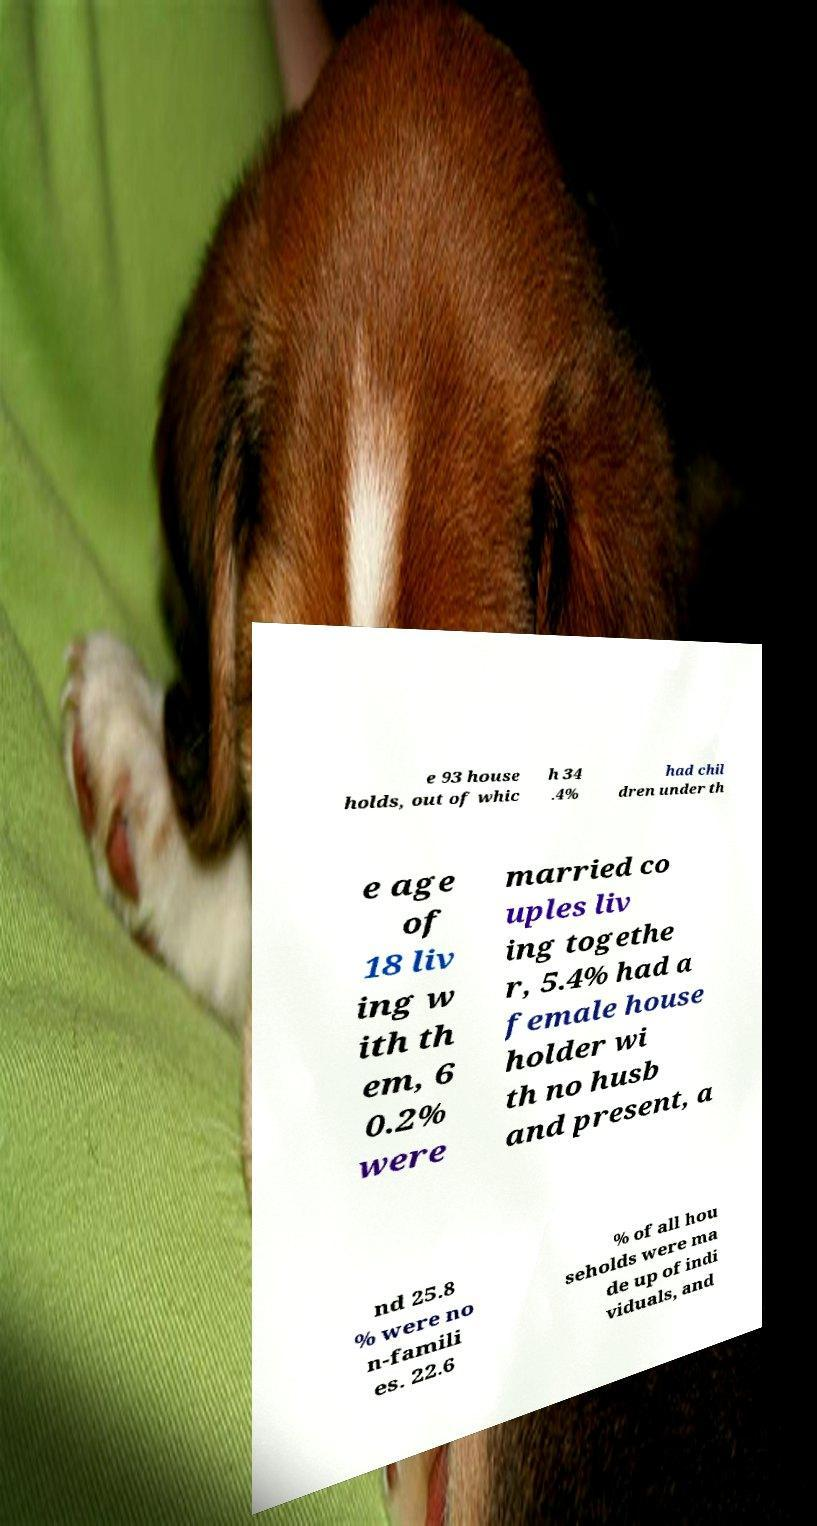Can you accurately transcribe the text from the provided image for me? e 93 house holds, out of whic h 34 .4% had chil dren under th e age of 18 liv ing w ith th em, 6 0.2% were married co uples liv ing togethe r, 5.4% had a female house holder wi th no husb and present, a nd 25.8 % were no n-famili es. 22.6 % of all hou seholds were ma de up of indi viduals, and 